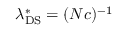Convert formula to latex. <formula><loc_0><loc_0><loc_500><loc_500>\lambda _ { D S } ^ { * } = ( N c ) ^ { - 1 }</formula> 